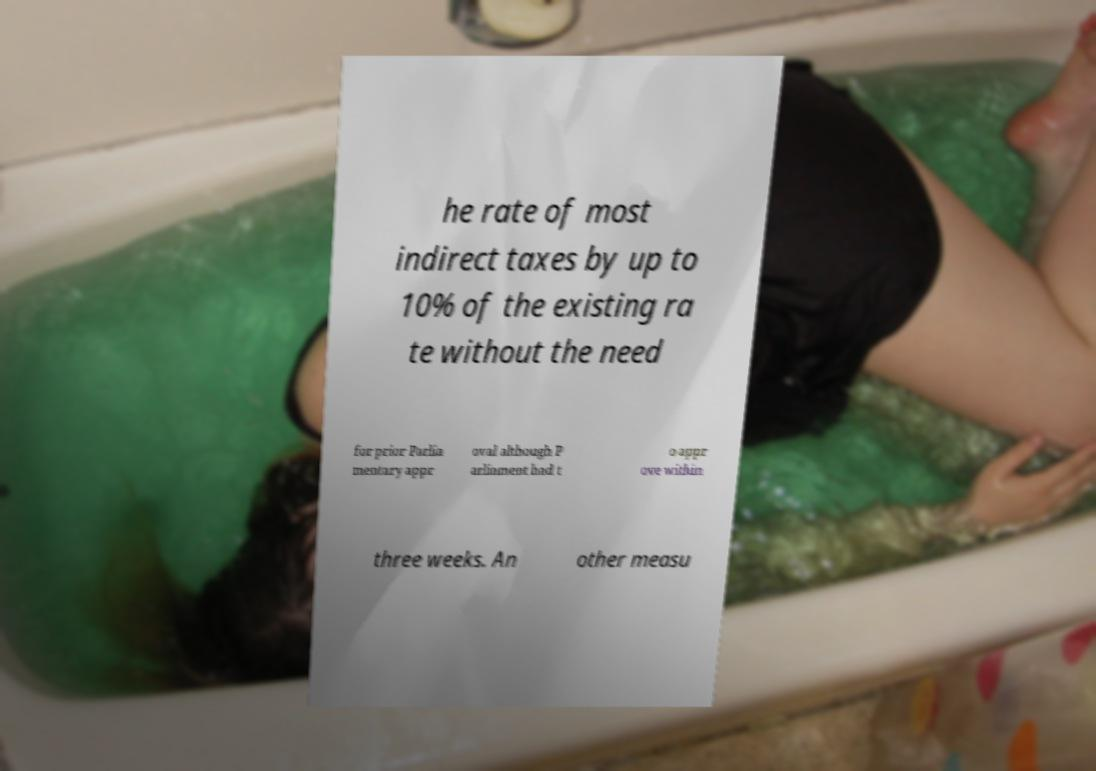There's text embedded in this image that I need extracted. Can you transcribe it verbatim? he rate of most indirect taxes by up to 10% of the existing ra te without the need for prior Parlia mentary appr oval although P arliament had t o appr ove within three weeks. An other measu 